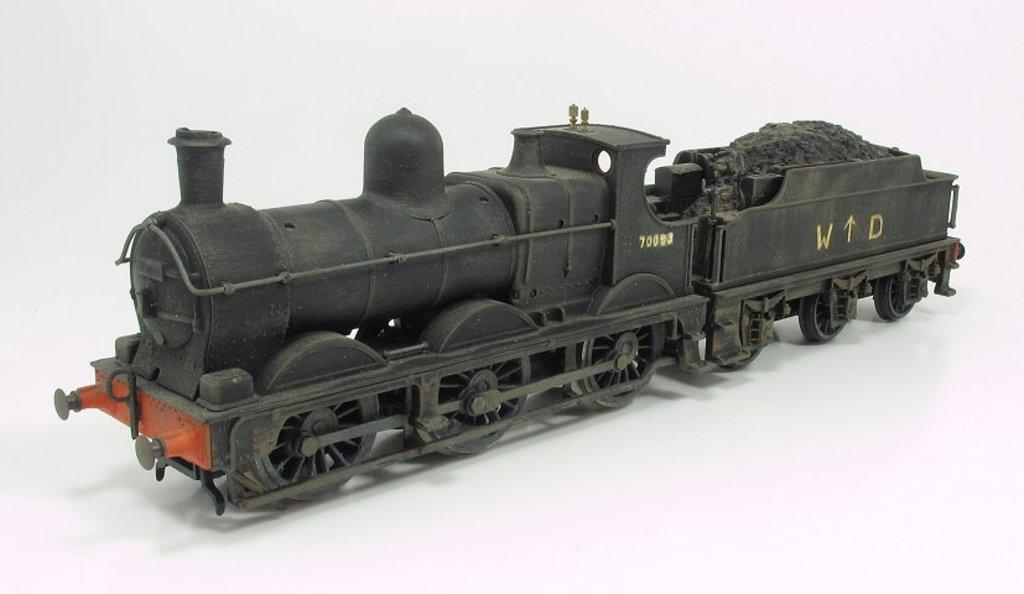What is the main subject of the image? The main subject of the image is a toy train. Can you describe the toy train in the image? The toy train is black in color. How many rabbits are sitting on the lap of the grandmother in the image? There is no grandmother or rabbits present in the image; it features a toy train. 